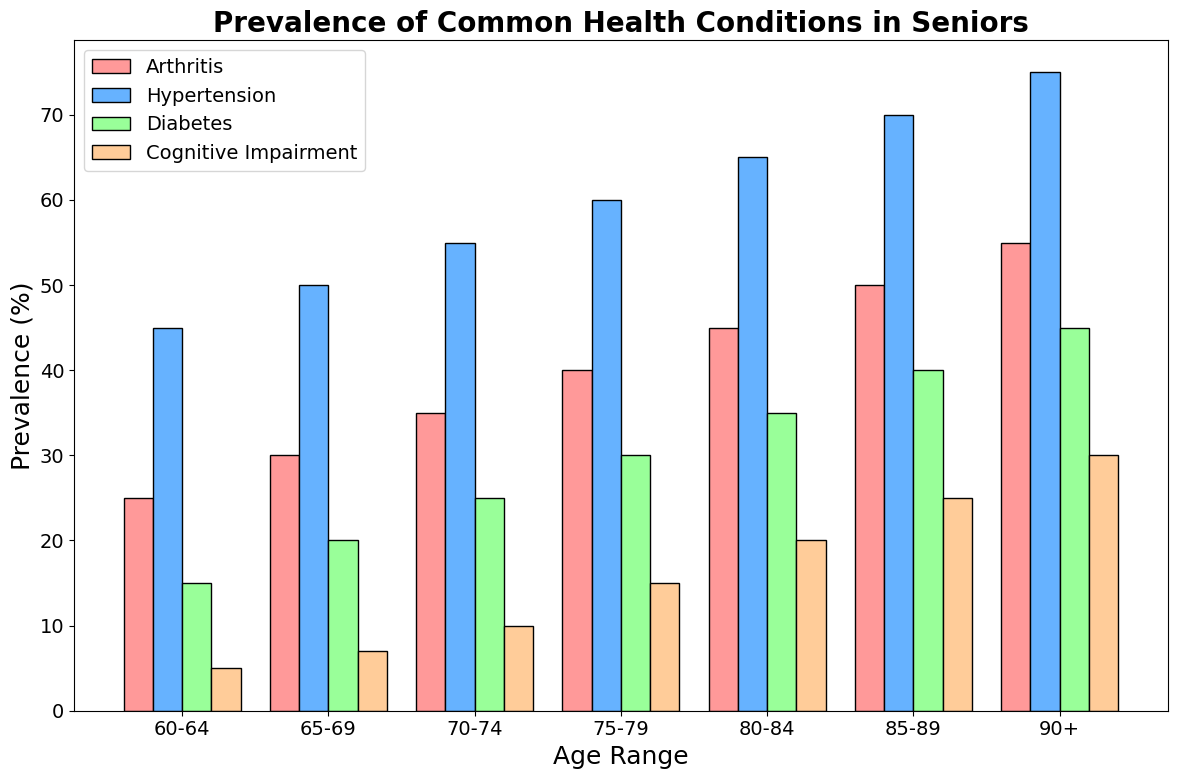What age range has the highest prevalence of hypertension? Look at the bars corresponding to hypertension (second group of bars in blue) and identify the age range with the tallest bar.
Answer: 90+ Which health condition has the lowest prevalence in the 80-84 age range? For the 80-84 age range, examine the heights of all four bars (red, blue, green, peach), and find the one with the shortest bar.
Answer: Cognitive Impairment How much higher is the prevalence of arthritis in the 85-89 age group compared to the 60-64 age group? Find the height of the red bar (arthritis) for both age groups (50% for 85-89 and 25% for 60-64) and subtract the smaller value from the larger one (50% - 25%).
Answer: 25% What is the average prevalence of cognitive impairment across all age groups? Add up the values of cognitive impairment (5, 7, 10, 15, 20, 25, 30) and divide by the number of age groups (7). The sum is (5+7+10+15+20+25+30) = 112. Dividing by 7 gives 112/7.
Answer: 16% Which age group has a higher prevalence of diabetes: 70-74 or 65-69? Compare the height of the green bars (diabetes) between the 70-74 age group (25%) and the 65-69 age group (20%).
Answer: 70-74 Is the prevalence of cognitive impairment in the 75-79 age range higher or lower than the prevalence of hypertension in the 60-64 age range? Compare the heights of the cognitive impairment bar (peach) for the 75-79 age group (15%) with the hypertension bar (blue) for the 60-64 age group (45%).
Answer: Lower Which health condition has the largest increase in prevalence from the 60-64 age group to the 90+ age group? Calculate the difference for each condition: Arthritis (55%-25% = 30%), Hypertension (75%-45% = 30%), Diabetes (45%-15% = 30%), and Cognitive Impairment (30%-5% = 25%). Then compare these differences.
Answer: Arthritis, Hypertension, and Diabetes (tied) In the 75-79 age range, what is the combined prevalence of arthritis and diabetes? Add the values of arthritis (40%) and diabetes (30%) for this age range.
Answer: 70% Which condition has a consistently increasing trend across all age ranges? Observe the trend for each condition by noting the bar heights across increasing age ranges. Arthritis, Hypertension, Diabetes, and Cognitive Impairment all show a consistent increase.
Answer: Arthritis, Hypertension, Diabetes, Cognitive Impairment What proportion of the 85-89 age group has hypertension compared to diabetes? Divide the prevalence of hypertension (70%) by that of diabetes (40%) and express it as a ratio or a factor. 70% / 40% = 1.75.
Answer: 1.75 